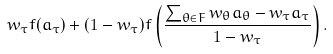Convert formula to latex. <formula><loc_0><loc_0><loc_500><loc_500>w _ { \tau } f ( a _ { \tau } ) + ( 1 - w _ { \tau } ) f \left ( \frac { \sum _ { \theta \in F } w _ { \theta } a _ { \theta } - w _ { \tau } a _ { \tau } } { 1 - w _ { \tau } } \right ) .</formula> 